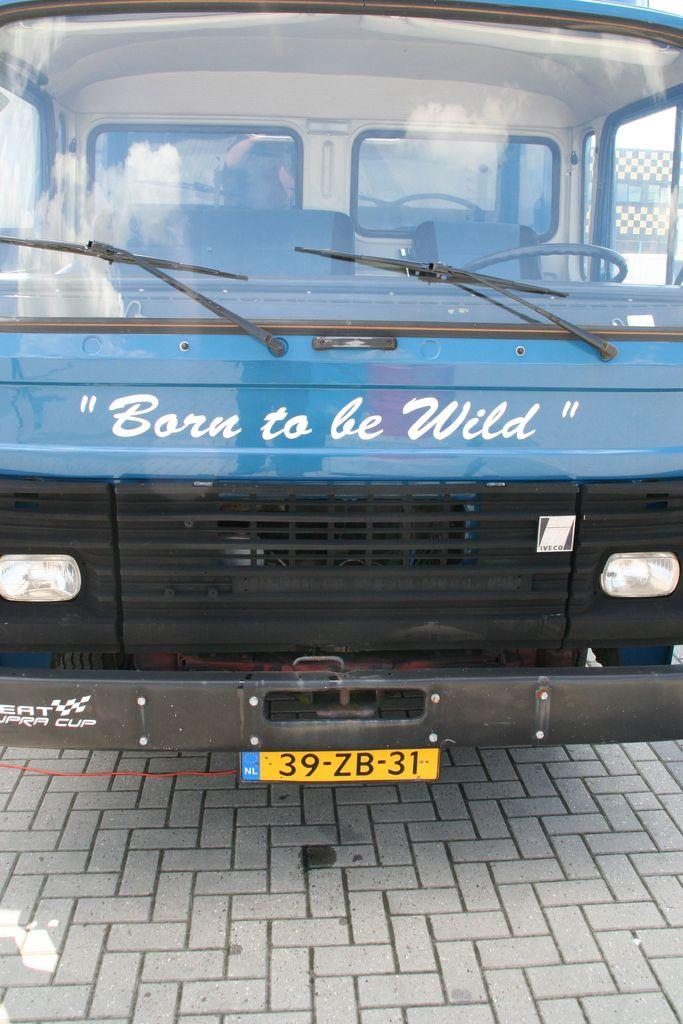<image>
Render a clear and concise summary of the photo. the blue vehicle says Born to be Wild on the front 